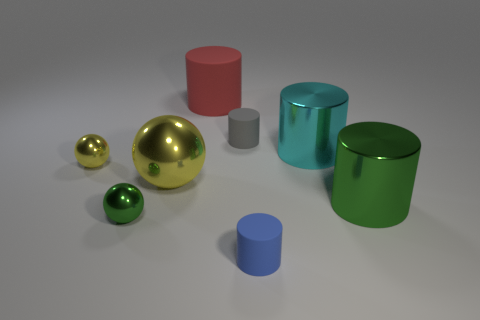There is a sphere that is behind the yellow sphere to the right of the tiny green thing; how big is it?
Offer a terse response. Small. Is the number of large cyan objects that are in front of the big yellow metal object the same as the number of gray objects that are on the left side of the green metallic sphere?
Your response must be concise. Yes. Is there any other thing that has the same size as the blue thing?
Your response must be concise. Yes. The big sphere that is the same material as the small green thing is what color?
Offer a very short reply. Yellow. Does the small yellow sphere have the same material as the cylinder that is in front of the green sphere?
Your answer should be compact. No. What color is the tiny object that is both in front of the big yellow shiny ball and on the left side of the large rubber cylinder?
Ensure brevity in your answer.  Green. What number of blocks are either gray matte things or green matte things?
Your answer should be compact. 0. There is a red thing; is it the same shape as the large metallic object that is left of the blue object?
Provide a succinct answer. No. There is a cylinder that is both in front of the big ball and on the left side of the cyan thing; how big is it?
Make the answer very short. Small. The tiny yellow object is what shape?
Make the answer very short. Sphere. 